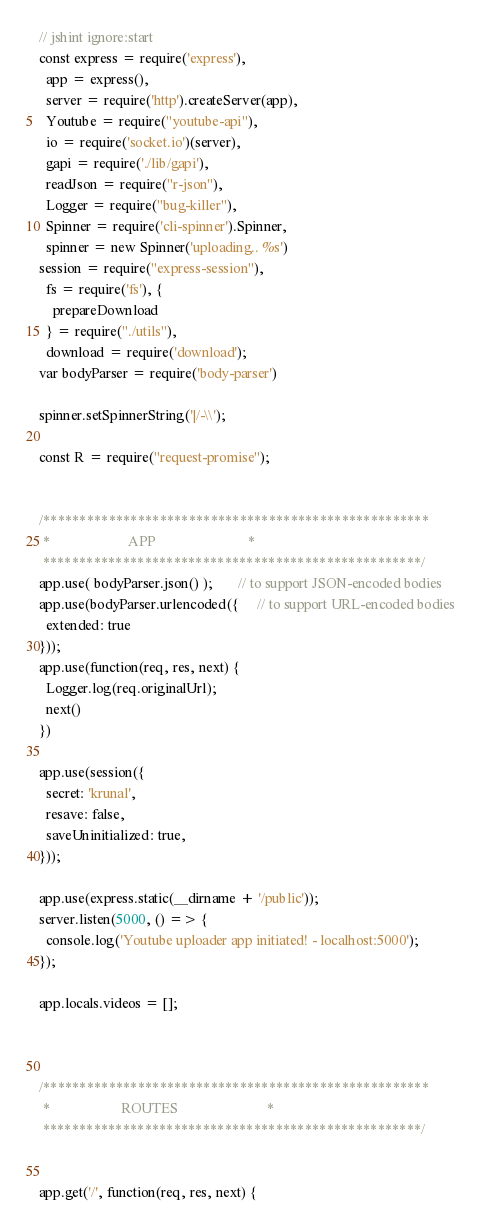Convert code to text. <code><loc_0><loc_0><loc_500><loc_500><_JavaScript_>// jshint ignore:start
const express = require('express'),
  app = express(),
  server = require('http').createServer(app),
  Youtube = require("youtube-api"),
  io = require('socket.io')(server),
  gapi = require('./lib/gapi'),
  readJson = require("r-json"),
  Logger = require("bug-killer"),
  Spinner = require('cli-spinner').Spinner,
  spinner = new Spinner('uploading.. %s')
session = require("express-session"),
  fs = require('fs'), {
    prepareDownload
  } = require("./utils"),
  download = require('download');
var bodyParser = require('body-parser')

spinner.setSpinnerString('|/-\\');

const R = require("request-promise");


/*****************************************************
 *                      APP                          *
 ****************************************************/
app.use( bodyParser.json() );       // to support JSON-encoded bodies
app.use(bodyParser.urlencoded({     // to support URL-encoded bodies
  extended: true
})); 
app.use(function(req, res, next) {
  Logger.log(req.originalUrl);
  next()
})

app.use(session({
  secret: 'krunal',
  resave: false,
  saveUninitialized: true,
}));

app.use(express.static(__dirname + '/public'));
server.listen(5000, () => {
  console.log('Youtube uploader app initiated! - localhost:5000');
});

app.locals.videos = [];



/*****************************************************
 *                    ROUTES                         *
 ****************************************************/


app.get('/', function(req, res, next) {</code> 